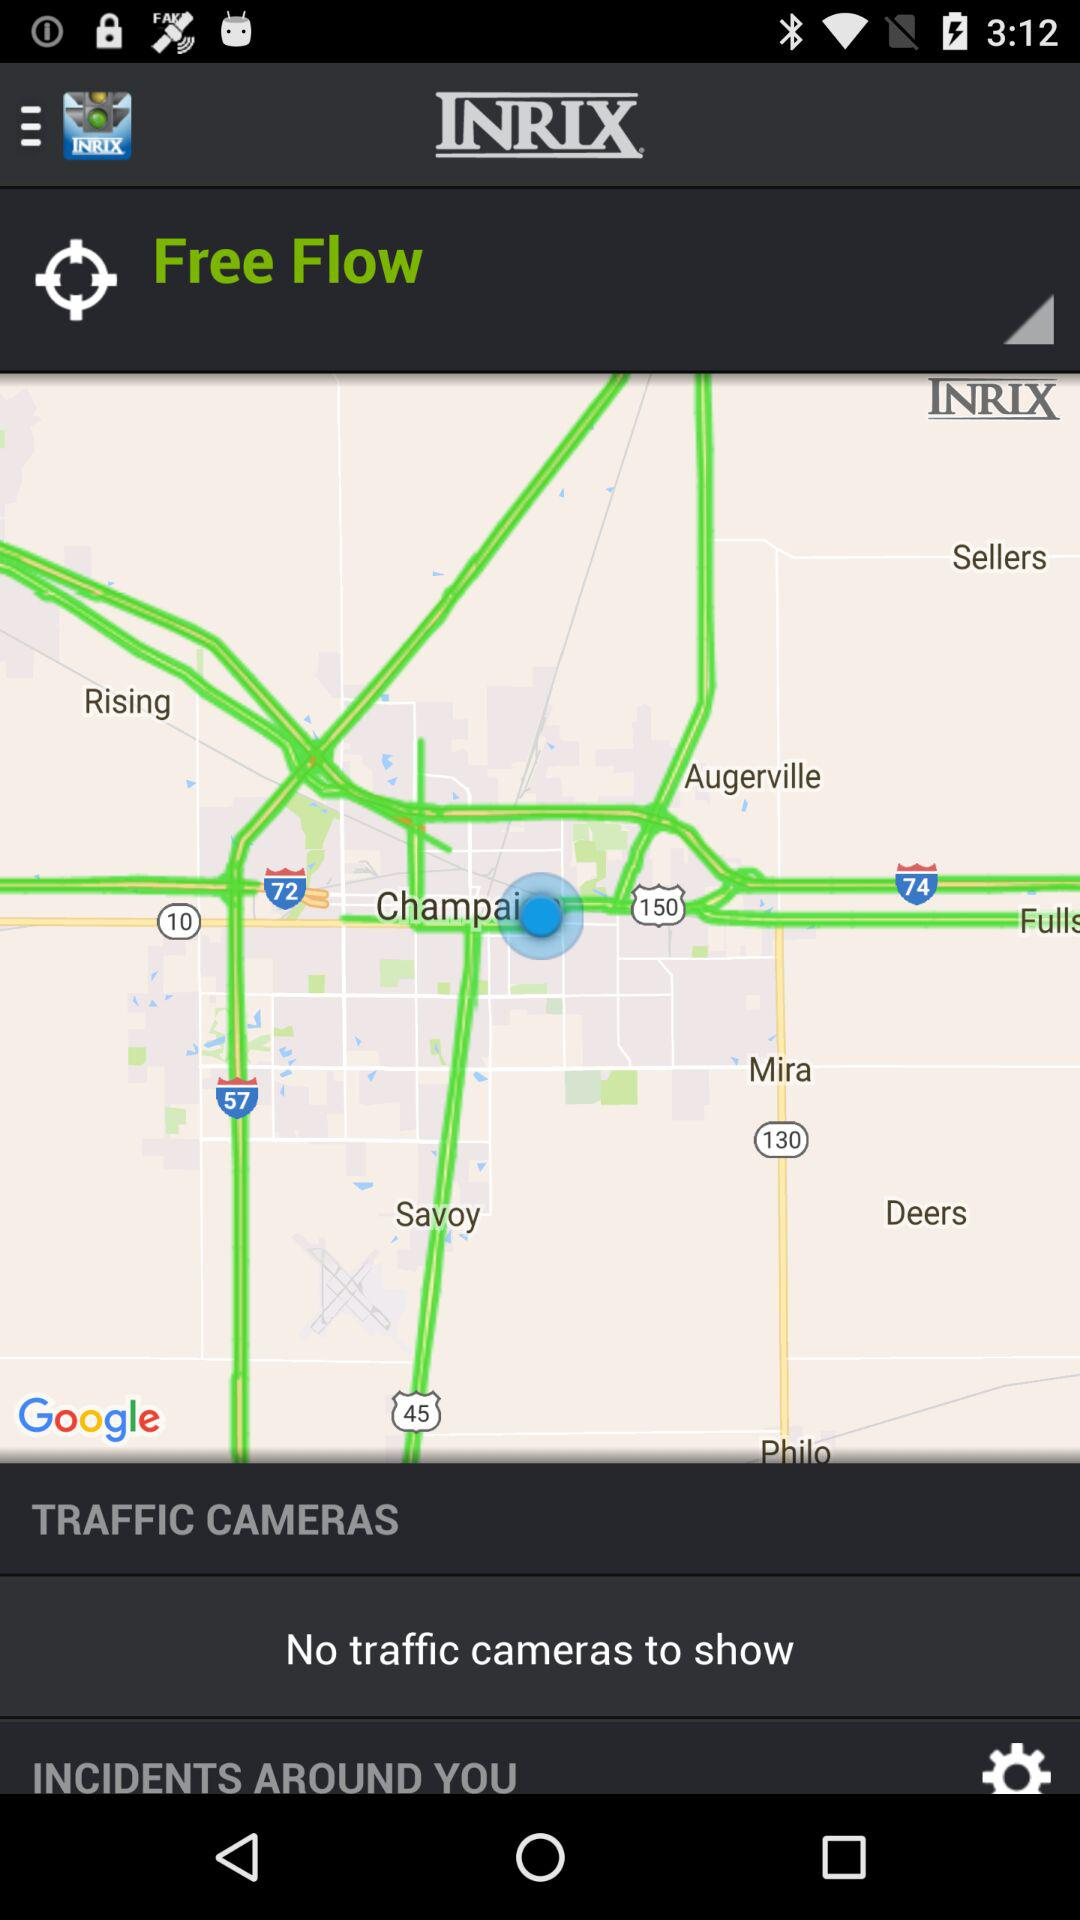How far away are the traffic cameras?
When the provided information is insufficient, respond with <no answer>. <no answer> 